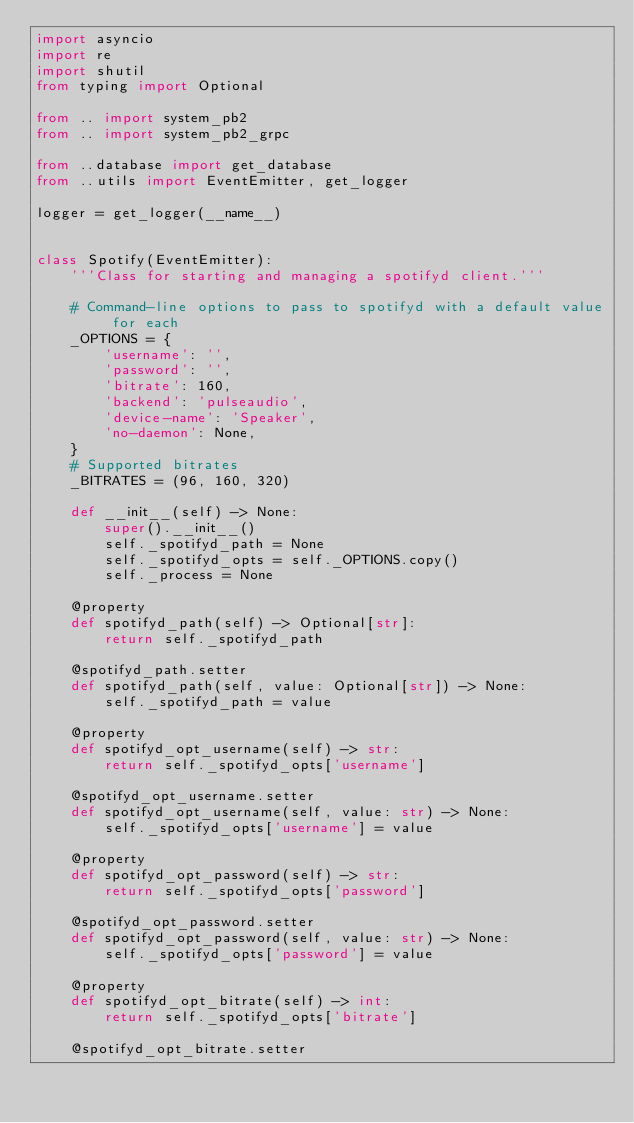Convert code to text. <code><loc_0><loc_0><loc_500><loc_500><_Python_>import asyncio
import re
import shutil
from typing import Optional

from .. import system_pb2
from .. import system_pb2_grpc

from ..database import get_database
from ..utils import EventEmitter, get_logger

logger = get_logger(__name__)


class Spotify(EventEmitter):
    '''Class for starting and managing a spotifyd client.'''

    # Command-line options to pass to spotifyd with a default value for each
    _OPTIONS = {
        'username': '',
        'password': '',
        'bitrate': 160,
        'backend': 'pulseaudio',
        'device-name': 'Speaker',
        'no-daemon': None,
    }
    # Supported bitrates
    _BITRATES = (96, 160, 320)

    def __init__(self) -> None:
        super().__init__()
        self._spotifyd_path = None
        self._spotifyd_opts = self._OPTIONS.copy()
        self._process = None

    @property
    def spotifyd_path(self) -> Optional[str]:
        return self._spotifyd_path

    @spotifyd_path.setter
    def spotifyd_path(self, value: Optional[str]) -> None:
        self._spotifyd_path = value

    @property
    def spotifyd_opt_username(self) -> str:
        return self._spotifyd_opts['username']

    @spotifyd_opt_username.setter
    def spotifyd_opt_username(self, value: str) -> None:
        self._spotifyd_opts['username'] = value

    @property
    def spotifyd_opt_password(self) -> str:
        return self._spotifyd_opts['password']

    @spotifyd_opt_password.setter
    def spotifyd_opt_password(self, value: str) -> None:
        self._spotifyd_opts['password'] = value

    @property
    def spotifyd_opt_bitrate(self) -> int:
        return self._spotifyd_opts['bitrate']

    @spotifyd_opt_bitrate.setter</code> 